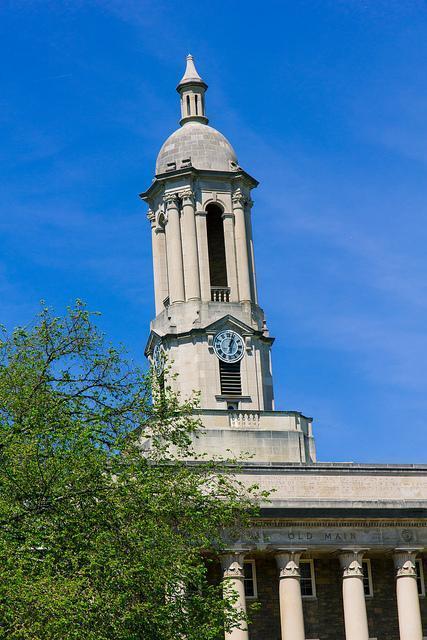How many clocks are on this tower?
Give a very brief answer. 1. 